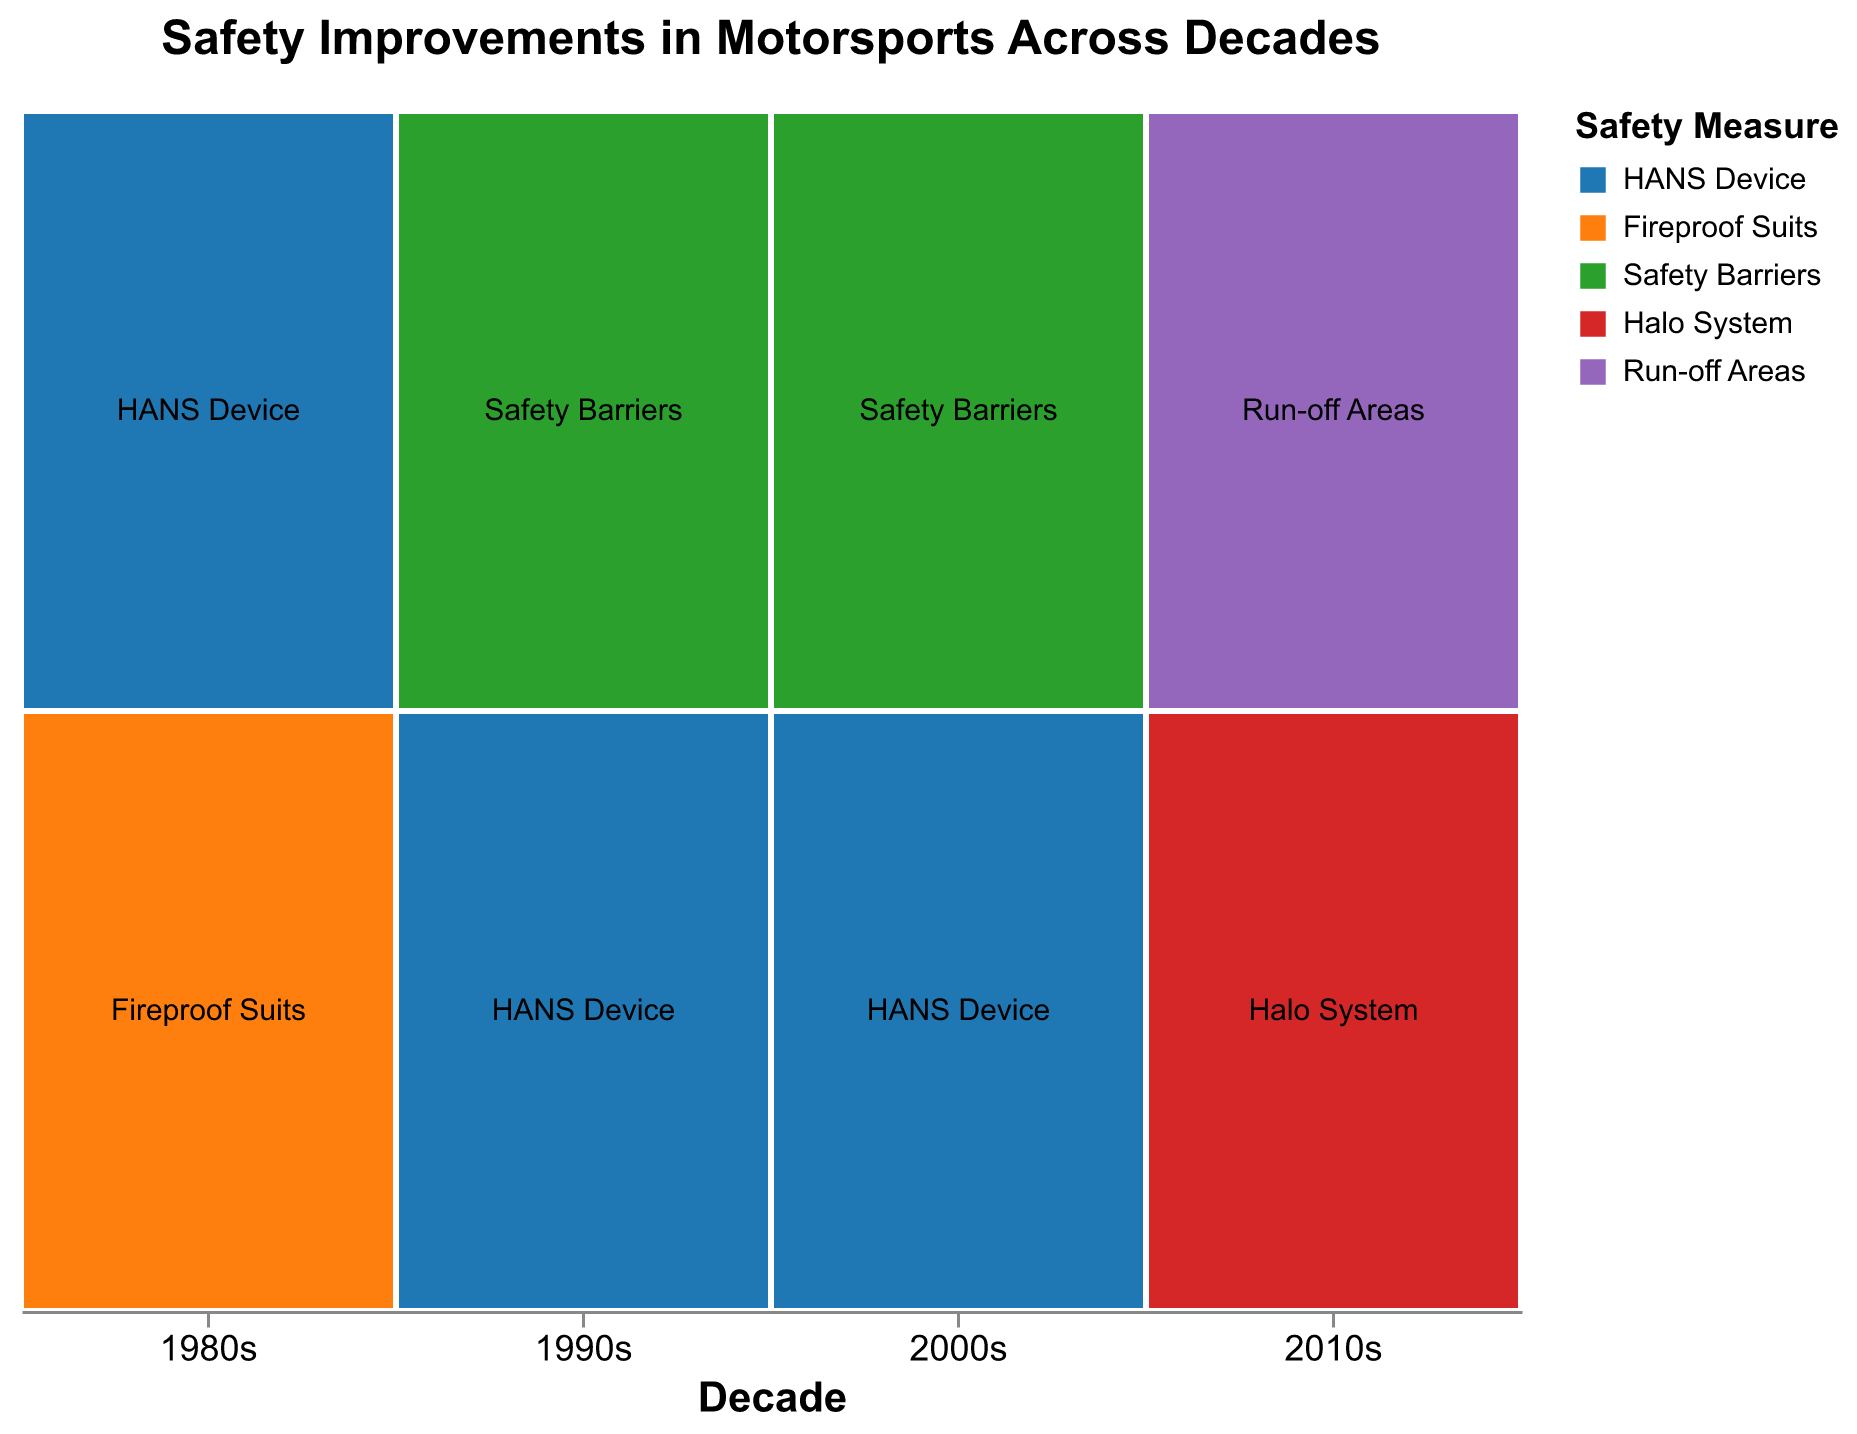What is the title of the figure? The title can be found at the top of the figure. It states, "Safety Improvements in Motorsports Across Decades".
Answer: Safety Improvements in Motorsports Across Decades How many different safety measures are shown for the 1980s? The figure shows two distinct colors under the 1980s section, representing different safety measures. They are labeled as "HANS Device" and "Fireproof Suits".
Answer: 2 Which decade shows the highest effectiveness rating for "HANS Device"? By examining the color representing "HANS Device" across the decades and its associated effectiveness, the 2000s show a "Very High" effectiveness, which is the highest.
Answer: 2000s Are the "Halo System" and "Run-off Areas" safety measures implemented in the same decade? The y-axis labels under the 2010s section show both "Halo System" and "Run-off Areas", indicating they were both implemented during the 2010s.
Answer: Yes Between the 1980s and 1990s, which decade saw fewer fatal accidents associated with the "HANS Device"? The number of fatal accidents for "HANS Device" in the 1980s and 1990s can be compared. The 1980s had 15 fatal accidents, while the 1990s had 8.
Answer: 1990s What is the effectiveness of "Fireproof Suits" safety measure in the 1980s? By looking at the color-coded segment for "Fireproof Suits" in the 1980s and checking the associated tooltip, the effectiveness is listed as "High".
Answer: High How does the number of injuries compare between "HANS Device" in the 1980s and 2000s? The injury count for "HANS Device" in the 1980s is 68, while in the 2000s it is 25. To compare, 68 is larger than 25.
Answer: 68 vs 25 Which safety measure in the 2010s had fewer fatal accidents, "Halo System" or "Run-off Areas"? By checking the number of fatal accidents for each safety measure in the 2010s, "Halo System" had 1 fatal accident, while "Run-off Areas" had 2.
Answer: Halo System Are there more safety measures with "High" effectiveness in the 2010s compared to the 1980s? By counting the safety measures with "High" effectiveness in the 2010s and 1980s, both decades have one measure each ("Run-off Areas" in the 2010s and "Fireproof Suits" in the 1980s).
Answer: No Which decade shows the implementation of a safety measure that resulted in the lowest number of injuries? By comparing injury counts across decades and safety measures, the "Halo System" in the 2010s shows the lowest number of injuries, which is 15.
Answer: 2010s 